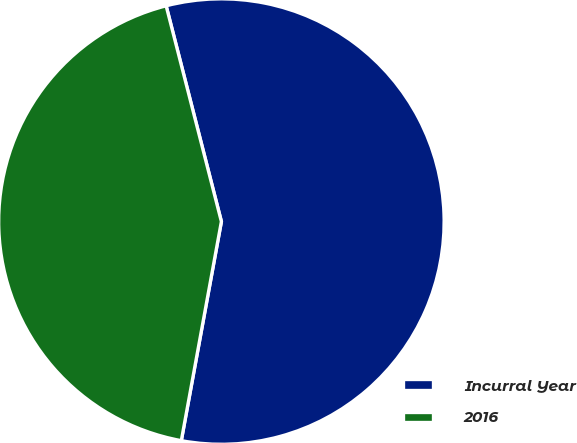Convert chart to OTSL. <chart><loc_0><loc_0><loc_500><loc_500><pie_chart><fcel>Incurral Year<fcel>2016<nl><fcel>56.87%<fcel>43.13%<nl></chart> 